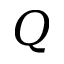Convert formula to latex. <formula><loc_0><loc_0><loc_500><loc_500>Q</formula> 